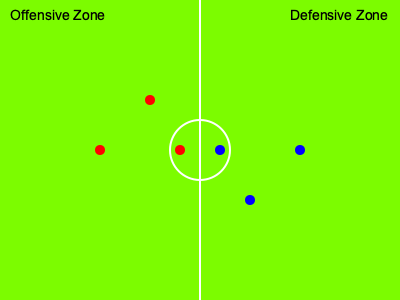In the lacrosse field diagram, red dots represent offensive players and blue dots represent defensive players. What strategic advantage does the positioning of the offensive player at coordinates (180, 150) provide? To understand the strategic advantage of the offensive player at (180, 150), let's analyze the positioning step-by-step:

1. Field layout: The diagram shows a lacrosse field divided into two halves, with a center circle.

2. Player distribution:
   - 3 red dots (offensive players) in the left half (offensive zone)
   - 3 blue dots (defensive players) in the right half (defensive zone)

3. Center positioning:
   - One red dot (180, 150) and one blue dot (220, 150) are near the center circle

4. Strategic analysis:
   a) The offensive player at (180, 150) is positioned just inside the center circle on the offensive side.
   b) This position is closer to the center than any other offensive player.
   c) Being near the center provides quick access to both sides of the field.
   d) The player can easily transition between offense and defense.
   e) This position is ideal for face-offs, allowing quick possession of the ball.
   f) The player can quickly distribute the ball to teammates in better scoring positions.
   g) The central position also allows for effective defensive transition if possession is lost.

5. Comparison to other players:
   - Other offensive players are positioned deeper in the offensive zone, focusing on scoring.
   - The centrally positioned player acts as a link between defense and offense.

The strategic advantage of this position is its versatility, allowing for quick transitions, ball distribution, and involvement in both offensive and defensive plays.
Answer: Versatile central positioning for quick transitions and ball distribution 